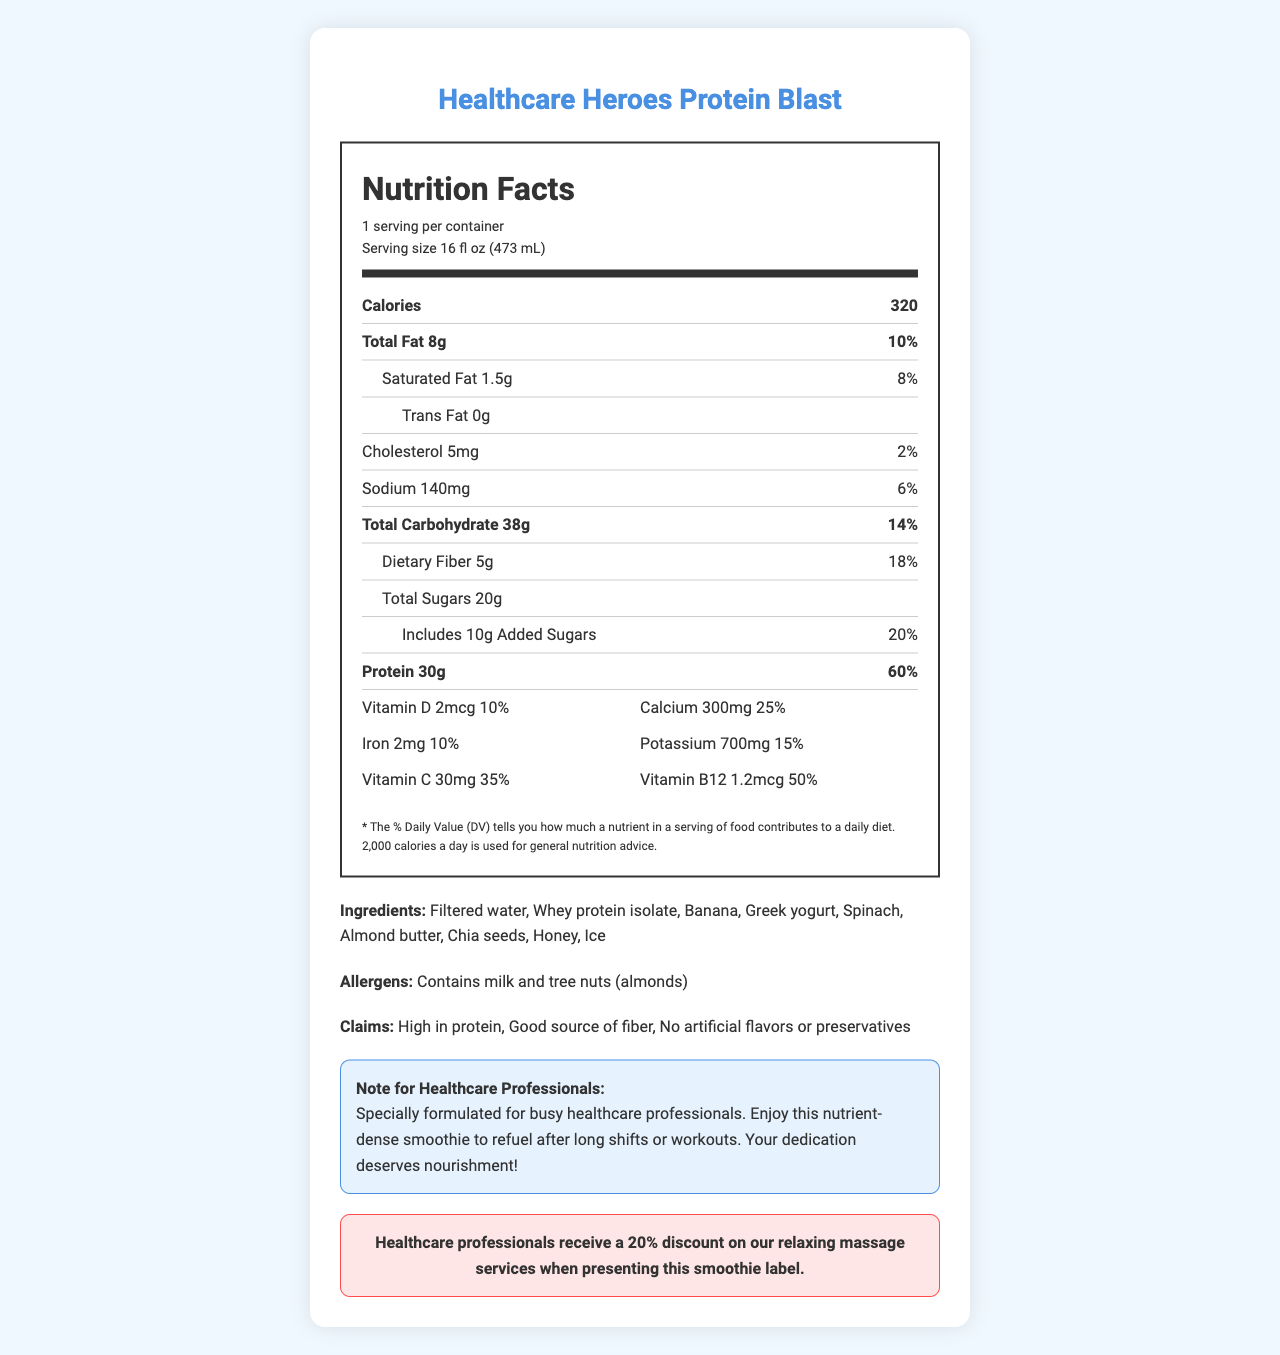What is the serving size of the "Healthcare Heroes Protein Blast"? The serving size is clearly stated under the product name and within the nutrition label section.
Answer: 16 fl oz (473 mL) How many calories are in one serving? The calories per serving are prominently displayed in the nutrition label section.
Answer: 320 How much protein does the smoothie provide per serving? The amount of protein per serving is mentioned in the nutrition facts panel as "Protein 30g".
Answer: 30g What is the % Daily Value of dietary fiber in this smoothie? The % Daily Value for dietary fiber is listed next to its amount in the nutrition label.
Answer: 18% Which vitamins are present in the smoothie? The vitamins and their amounts are listed in the vitamins section of the nutrition label.
Answer: Vitamin D, Calcium, Iron, Potassium, Vitamin C, Vitamin B12 What ingredient is used in this smoothie as a protein source? The ingredient list includes "Whey protein isolate" as the protein source.
Answer: Whey protein isolate How many grams of added sugars are there in the smoothie? The amount of added sugars is specified in the nutrition label under the "Total Sugars" section.
Answer: 10g What is the primary health claim made about this smoothie? A. High in fiber B. High in protein C. Low in calories D. Sugar-free The health claims section states "High in protein" as one of its claims.
Answer: B. High in protein Which of the following nutrients has the highest % Daily Value per serving? A. Saturated Fat B. Sodium C. Protein D. Vitamin C Protein has a % Daily Value of 60%, which is the highest among the listed options.
Answer: C. Protein Does this product contain trans fat? The nutrition label specifies "Trans Fat 0g".
Answer: No Is this smoothie suitable for someone with a tree nut allergy? The allergens section mentions that it contains tree nuts (almonds).
Answer: No Summarize the purpose of the "Healthcare Heroes Protein Blast" smoothie. The healthcare professional note and the claims provide a clear idea that this product is intended to offer nourishment and support to healthcare professionals, with a particular emphasis on protein and nutritional quality.
Answer: It is a protein-rich, nutrient-dense smoothie designed for healthcare professionals to refuel after long shifts or workouts with a focus on high protein content and key vitamins and minerals, free from artificial flavors or preservatives. What is the source of fiber in this smoothie? The document lists "Spinach" and "Chia seeds" as ingredients, which can be sources of fiber, but it does not clearly specify the primary source.
Answer: Not enough information 